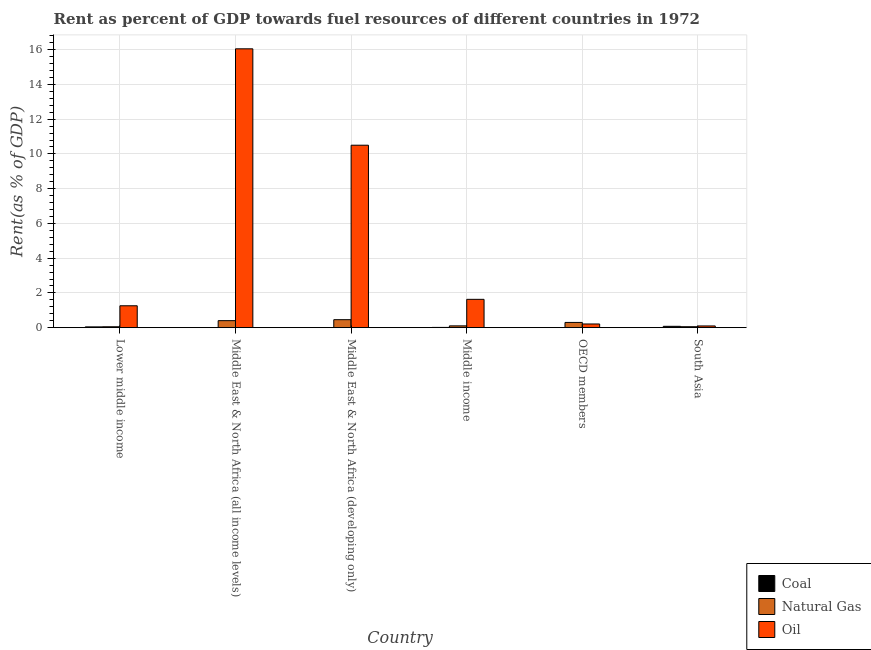How many groups of bars are there?
Provide a short and direct response. 6. Are the number of bars on each tick of the X-axis equal?
Provide a succinct answer. Yes. What is the label of the 6th group of bars from the left?
Your answer should be very brief. South Asia. In how many cases, is the number of bars for a given country not equal to the number of legend labels?
Offer a very short reply. 0. What is the rent towards coal in South Asia?
Ensure brevity in your answer.  0.08. Across all countries, what is the maximum rent towards coal?
Provide a succinct answer. 0.08. Across all countries, what is the minimum rent towards coal?
Make the answer very short. 2.27630170157113e-6. In which country was the rent towards natural gas maximum?
Give a very brief answer. Middle East & North Africa (developing only). In which country was the rent towards coal minimum?
Your answer should be compact. OECD members. What is the total rent towards coal in the graph?
Keep it short and to the point. 0.14. What is the difference between the rent towards coal in Middle East & North Africa (developing only) and that in Middle income?
Offer a terse response. -0.01. What is the difference between the rent towards coal in Lower middle income and the rent towards oil in OECD members?
Provide a short and direct response. -0.17. What is the average rent towards natural gas per country?
Keep it short and to the point. 0.23. What is the difference between the rent towards oil and rent towards coal in OECD members?
Offer a terse response. 0.21. In how many countries, is the rent towards natural gas greater than 6 %?
Ensure brevity in your answer.  0. What is the ratio of the rent towards natural gas in Middle East & North Africa (developing only) to that in South Asia?
Ensure brevity in your answer.  8.35. Is the difference between the rent towards oil in Middle East & North Africa (developing only) and Middle income greater than the difference between the rent towards natural gas in Middle East & North Africa (developing only) and Middle income?
Ensure brevity in your answer.  Yes. What is the difference between the highest and the second highest rent towards natural gas?
Your answer should be compact. 0.06. What is the difference between the highest and the lowest rent towards oil?
Your answer should be very brief. 15.95. Is the sum of the rent towards natural gas in Middle East & North Africa (all income levels) and Middle East & North Africa (developing only) greater than the maximum rent towards coal across all countries?
Provide a succinct answer. Yes. What does the 2nd bar from the left in South Asia represents?
Provide a short and direct response. Natural Gas. What does the 2nd bar from the right in Lower middle income represents?
Keep it short and to the point. Natural Gas. What is the difference between two consecutive major ticks on the Y-axis?
Your response must be concise. 2. Does the graph contain any zero values?
Give a very brief answer. No. Where does the legend appear in the graph?
Offer a very short reply. Bottom right. How are the legend labels stacked?
Offer a terse response. Vertical. What is the title of the graph?
Offer a very short reply. Rent as percent of GDP towards fuel resources of different countries in 1972. Does "Ages 0-14" appear as one of the legend labels in the graph?
Provide a succinct answer. No. What is the label or title of the X-axis?
Provide a short and direct response. Country. What is the label or title of the Y-axis?
Offer a very short reply. Rent(as % of GDP). What is the Rent(as % of GDP) of Coal in Lower middle income?
Keep it short and to the point. 0.04. What is the Rent(as % of GDP) in Natural Gas in Lower middle income?
Offer a very short reply. 0.05. What is the Rent(as % of GDP) of Oil in Lower middle income?
Your answer should be compact. 1.26. What is the Rent(as % of GDP) in Coal in Middle East & North Africa (all income levels)?
Your answer should be compact. 0. What is the Rent(as % of GDP) of Natural Gas in Middle East & North Africa (all income levels)?
Keep it short and to the point. 0.4. What is the Rent(as % of GDP) in Oil in Middle East & North Africa (all income levels)?
Give a very brief answer. 16.05. What is the Rent(as % of GDP) of Coal in Middle East & North Africa (developing only)?
Give a very brief answer. 0. What is the Rent(as % of GDP) of Natural Gas in Middle East & North Africa (developing only)?
Your response must be concise. 0.46. What is the Rent(as % of GDP) in Oil in Middle East & North Africa (developing only)?
Your answer should be very brief. 10.5. What is the Rent(as % of GDP) in Coal in Middle income?
Your answer should be very brief. 0.01. What is the Rent(as % of GDP) of Natural Gas in Middle income?
Give a very brief answer. 0.1. What is the Rent(as % of GDP) in Oil in Middle income?
Your response must be concise. 1.63. What is the Rent(as % of GDP) in Coal in OECD members?
Your answer should be compact. 2.27630170157113e-6. What is the Rent(as % of GDP) of Natural Gas in OECD members?
Give a very brief answer. 0.3. What is the Rent(as % of GDP) in Oil in OECD members?
Provide a succinct answer. 0.21. What is the Rent(as % of GDP) in Coal in South Asia?
Your answer should be compact. 0.08. What is the Rent(as % of GDP) in Natural Gas in South Asia?
Provide a short and direct response. 0.06. What is the Rent(as % of GDP) of Oil in South Asia?
Ensure brevity in your answer.  0.1. Across all countries, what is the maximum Rent(as % of GDP) of Coal?
Give a very brief answer. 0.08. Across all countries, what is the maximum Rent(as % of GDP) in Natural Gas?
Ensure brevity in your answer.  0.46. Across all countries, what is the maximum Rent(as % of GDP) of Oil?
Offer a terse response. 16.05. Across all countries, what is the minimum Rent(as % of GDP) of Coal?
Ensure brevity in your answer.  2.27630170157113e-6. Across all countries, what is the minimum Rent(as % of GDP) of Natural Gas?
Your answer should be compact. 0.05. Across all countries, what is the minimum Rent(as % of GDP) in Oil?
Ensure brevity in your answer.  0.1. What is the total Rent(as % of GDP) in Coal in the graph?
Your answer should be compact. 0.14. What is the total Rent(as % of GDP) of Natural Gas in the graph?
Provide a short and direct response. 1.37. What is the total Rent(as % of GDP) of Oil in the graph?
Your response must be concise. 29.76. What is the difference between the Rent(as % of GDP) in Coal in Lower middle income and that in Middle East & North Africa (all income levels)?
Your answer should be very brief. 0.04. What is the difference between the Rent(as % of GDP) of Natural Gas in Lower middle income and that in Middle East & North Africa (all income levels)?
Provide a succinct answer. -0.35. What is the difference between the Rent(as % of GDP) of Oil in Lower middle income and that in Middle East & North Africa (all income levels)?
Make the answer very short. -14.79. What is the difference between the Rent(as % of GDP) in Coal in Lower middle income and that in Middle East & North Africa (developing only)?
Offer a terse response. 0.04. What is the difference between the Rent(as % of GDP) of Natural Gas in Lower middle income and that in Middle East & North Africa (developing only)?
Provide a succinct answer. -0.41. What is the difference between the Rent(as % of GDP) of Oil in Lower middle income and that in Middle East & North Africa (developing only)?
Offer a very short reply. -9.24. What is the difference between the Rent(as % of GDP) of Natural Gas in Lower middle income and that in Middle income?
Make the answer very short. -0.05. What is the difference between the Rent(as % of GDP) in Oil in Lower middle income and that in Middle income?
Your answer should be very brief. -0.37. What is the difference between the Rent(as % of GDP) of Coal in Lower middle income and that in OECD members?
Your response must be concise. 0.04. What is the difference between the Rent(as % of GDP) in Natural Gas in Lower middle income and that in OECD members?
Provide a succinct answer. -0.25. What is the difference between the Rent(as % of GDP) in Oil in Lower middle income and that in OECD members?
Ensure brevity in your answer.  1.05. What is the difference between the Rent(as % of GDP) of Coal in Lower middle income and that in South Asia?
Make the answer very short. -0.03. What is the difference between the Rent(as % of GDP) of Natural Gas in Lower middle income and that in South Asia?
Ensure brevity in your answer.  -0. What is the difference between the Rent(as % of GDP) in Oil in Lower middle income and that in South Asia?
Your answer should be very brief. 1.16. What is the difference between the Rent(as % of GDP) of Coal in Middle East & North Africa (all income levels) and that in Middle East & North Africa (developing only)?
Give a very brief answer. -0. What is the difference between the Rent(as % of GDP) of Natural Gas in Middle East & North Africa (all income levels) and that in Middle East & North Africa (developing only)?
Provide a short and direct response. -0.06. What is the difference between the Rent(as % of GDP) of Oil in Middle East & North Africa (all income levels) and that in Middle East & North Africa (developing only)?
Make the answer very short. 5.55. What is the difference between the Rent(as % of GDP) in Coal in Middle East & North Africa (all income levels) and that in Middle income?
Give a very brief answer. -0.01. What is the difference between the Rent(as % of GDP) of Natural Gas in Middle East & North Africa (all income levels) and that in Middle income?
Your answer should be very brief. 0.3. What is the difference between the Rent(as % of GDP) in Oil in Middle East & North Africa (all income levels) and that in Middle income?
Ensure brevity in your answer.  14.42. What is the difference between the Rent(as % of GDP) in Natural Gas in Middle East & North Africa (all income levels) and that in OECD members?
Give a very brief answer. 0.1. What is the difference between the Rent(as % of GDP) in Oil in Middle East & North Africa (all income levels) and that in OECD members?
Your answer should be compact. 15.84. What is the difference between the Rent(as % of GDP) in Coal in Middle East & North Africa (all income levels) and that in South Asia?
Ensure brevity in your answer.  -0.08. What is the difference between the Rent(as % of GDP) in Natural Gas in Middle East & North Africa (all income levels) and that in South Asia?
Make the answer very short. 0.35. What is the difference between the Rent(as % of GDP) in Oil in Middle East & North Africa (all income levels) and that in South Asia?
Provide a succinct answer. 15.95. What is the difference between the Rent(as % of GDP) of Coal in Middle East & North Africa (developing only) and that in Middle income?
Ensure brevity in your answer.  -0.01. What is the difference between the Rent(as % of GDP) of Natural Gas in Middle East & North Africa (developing only) and that in Middle income?
Make the answer very short. 0.36. What is the difference between the Rent(as % of GDP) of Oil in Middle East & North Africa (developing only) and that in Middle income?
Offer a very short reply. 8.87. What is the difference between the Rent(as % of GDP) of Coal in Middle East & North Africa (developing only) and that in OECD members?
Your answer should be compact. 0. What is the difference between the Rent(as % of GDP) in Natural Gas in Middle East & North Africa (developing only) and that in OECD members?
Offer a very short reply. 0.16. What is the difference between the Rent(as % of GDP) of Oil in Middle East & North Africa (developing only) and that in OECD members?
Provide a succinct answer. 10.29. What is the difference between the Rent(as % of GDP) of Coal in Middle East & North Africa (developing only) and that in South Asia?
Provide a short and direct response. -0.08. What is the difference between the Rent(as % of GDP) in Natural Gas in Middle East & North Africa (developing only) and that in South Asia?
Your answer should be compact. 0.4. What is the difference between the Rent(as % of GDP) in Oil in Middle East & North Africa (developing only) and that in South Asia?
Your answer should be very brief. 10.4. What is the difference between the Rent(as % of GDP) of Coal in Middle income and that in OECD members?
Keep it short and to the point. 0.01. What is the difference between the Rent(as % of GDP) of Natural Gas in Middle income and that in OECD members?
Your answer should be compact. -0.2. What is the difference between the Rent(as % of GDP) of Oil in Middle income and that in OECD members?
Your answer should be compact. 1.42. What is the difference between the Rent(as % of GDP) in Coal in Middle income and that in South Asia?
Offer a terse response. -0.06. What is the difference between the Rent(as % of GDP) of Natural Gas in Middle income and that in South Asia?
Your answer should be very brief. 0.05. What is the difference between the Rent(as % of GDP) in Oil in Middle income and that in South Asia?
Your response must be concise. 1.53. What is the difference between the Rent(as % of GDP) in Coal in OECD members and that in South Asia?
Provide a short and direct response. -0.08. What is the difference between the Rent(as % of GDP) in Natural Gas in OECD members and that in South Asia?
Your answer should be very brief. 0.25. What is the difference between the Rent(as % of GDP) in Oil in OECD members and that in South Asia?
Offer a very short reply. 0.11. What is the difference between the Rent(as % of GDP) in Coal in Lower middle income and the Rent(as % of GDP) in Natural Gas in Middle East & North Africa (all income levels)?
Give a very brief answer. -0.36. What is the difference between the Rent(as % of GDP) of Coal in Lower middle income and the Rent(as % of GDP) of Oil in Middle East & North Africa (all income levels)?
Ensure brevity in your answer.  -16.01. What is the difference between the Rent(as % of GDP) in Natural Gas in Lower middle income and the Rent(as % of GDP) in Oil in Middle East & North Africa (all income levels)?
Provide a succinct answer. -16. What is the difference between the Rent(as % of GDP) in Coal in Lower middle income and the Rent(as % of GDP) in Natural Gas in Middle East & North Africa (developing only)?
Offer a terse response. -0.41. What is the difference between the Rent(as % of GDP) of Coal in Lower middle income and the Rent(as % of GDP) of Oil in Middle East & North Africa (developing only)?
Keep it short and to the point. -10.46. What is the difference between the Rent(as % of GDP) in Natural Gas in Lower middle income and the Rent(as % of GDP) in Oil in Middle East & North Africa (developing only)?
Your answer should be compact. -10.45. What is the difference between the Rent(as % of GDP) of Coal in Lower middle income and the Rent(as % of GDP) of Natural Gas in Middle income?
Provide a succinct answer. -0.06. What is the difference between the Rent(as % of GDP) of Coal in Lower middle income and the Rent(as % of GDP) of Oil in Middle income?
Your response must be concise. -1.59. What is the difference between the Rent(as % of GDP) of Natural Gas in Lower middle income and the Rent(as % of GDP) of Oil in Middle income?
Offer a terse response. -1.58. What is the difference between the Rent(as % of GDP) in Coal in Lower middle income and the Rent(as % of GDP) in Natural Gas in OECD members?
Provide a short and direct response. -0.26. What is the difference between the Rent(as % of GDP) of Coal in Lower middle income and the Rent(as % of GDP) of Oil in OECD members?
Your answer should be compact. -0.17. What is the difference between the Rent(as % of GDP) in Natural Gas in Lower middle income and the Rent(as % of GDP) in Oil in OECD members?
Make the answer very short. -0.16. What is the difference between the Rent(as % of GDP) in Coal in Lower middle income and the Rent(as % of GDP) in Natural Gas in South Asia?
Offer a very short reply. -0.01. What is the difference between the Rent(as % of GDP) in Coal in Lower middle income and the Rent(as % of GDP) in Oil in South Asia?
Ensure brevity in your answer.  -0.05. What is the difference between the Rent(as % of GDP) of Natural Gas in Lower middle income and the Rent(as % of GDP) of Oil in South Asia?
Give a very brief answer. -0.05. What is the difference between the Rent(as % of GDP) in Coal in Middle East & North Africa (all income levels) and the Rent(as % of GDP) in Natural Gas in Middle East & North Africa (developing only)?
Your answer should be very brief. -0.46. What is the difference between the Rent(as % of GDP) in Coal in Middle East & North Africa (all income levels) and the Rent(as % of GDP) in Oil in Middle East & North Africa (developing only)?
Ensure brevity in your answer.  -10.5. What is the difference between the Rent(as % of GDP) in Natural Gas in Middle East & North Africa (all income levels) and the Rent(as % of GDP) in Oil in Middle East & North Africa (developing only)?
Ensure brevity in your answer.  -10.1. What is the difference between the Rent(as % of GDP) in Coal in Middle East & North Africa (all income levels) and the Rent(as % of GDP) in Natural Gas in Middle income?
Provide a succinct answer. -0.1. What is the difference between the Rent(as % of GDP) in Coal in Middle East & North Africa (all income levels) and the Rent(as % of GDP) in Oil in Middle income?
Your answer should be compact. -1.63. What is the difference between the Rent(as % of GDP) of Natural Gas in Middle East & North Africa (all income levels) and the Rent(as % of GDP) of Oil in Middle income?
Offer a very short reply. -1.23. What is the difference between the Rent(as % of GDP) in Coal in Middle East & North Africa (all income levels) and the Rent(as % of GDP) in Natural Gas in OECD members?
Your answer should be very brief. -0.3. What is the difference between the Rent(as % of GDP) of Coal in Middle East & North Africa (all income levels) and the Rent(as % of GDP) of Oil in OECD members?
Give a very brief answer. -0.21. What is the difference between the Rent(as % of GDP) in Natural Gas in Middle East & North Africa (all income levels) and the Rent(as % of GDP) in Oil in OECD members?
Ensure brevity in your answer.  0.19. What is the difference between the Rent(as % of GDP) of Coal in Middle East & North Africa (all income levels) and the Rent(as % of GDP) of Natural Gas in South Asia?
Your response must be concise. -0.05. What is the difference between the Rent(as % of GDP) of Coal in Middle East & North Africa (all income levels) and the Rent(as % of GDP) of Oil in South Asia?
Make the answer very short. -0.1. What is the difference between the Rent(as % of GDP) of Natural Gas in Middle East & North Africa (all income levels) and the Rent(as % of GDP) of Oil in South Asia?
Ensure brevity in your answer.  0.3. What is the difference between the Rent(as % of GDP) of Coal in Middle East & North Africa (developing only) and the Rent(as % of GDP) of Natural Gas in Middle income?
Ensure brevity in your answer.  -0.1. What is the difference between the Rent(as % of GDP) in Coal in Middle East & North Africa (developing only) and the Rent(as % of GDP) in Oil in Middle income?
Your answer should be compact. -1.63. What is the difference between the Rent(as % of GDP) in Natural Gas in Middle East & North Africa (developing only) and the Rent(as % of GDP) in Oil in Middle income?
Your response must be concise. -1.17. What is the difference between the Rent(as % of GDP) in Coal in Middle East & North Africa (developing only) and the Rent(as % of GDP) in Natural Gas in OECD members?
Give a very brief answer. -0.3. What is the difference between the Rent(as % of GDP) of Coal in Middle East & North Africa (developing only) and the Rent(as % of GDP) of Oil in OECD members?
Your response must be concise. -0.21. What is the difference between the Rent(as % of GDP) in Natural Gas in Middle East & North Africa (developing only) and the Rent(as % of GDP) in Oil in OECD members?
Your response must be concise. 0.25. What is the difference between the Rent(as % of GDP) of Coal in Middle East & North Africa (developing only) and the Rent(as % of GDP) of Natural Gas in South Asia?
Your response must be concise. -0.05. What is the difference between the Rent(as % of GDP) in Coal in Middle East & North Africa (developing only) and the Rent(as % of GDP) in Oil in South Asia?
Offer a terse response. -0.1. What is the difference between the Rent(as % of GDP) in Natural Gas in Middle East & North Africa (developing only) and the Rent(as % of GDP) in Oil in South Asia?
Offer a terse response. 0.36. What is the difference between the Rent(as % of GDP) in Coal in Middle income and the Rent(as % of GDP) in Natural Gas in OECD members?
Make the answer very short. -0.29. What is the difference between the Rent(as % of GDP) in Coal in Middle income and the Rent(as % of GDP) in Oil in OECD members?
Provide a short and direct response. -0.2. What is the difference between the Rent(as % of GDP) in Natural Gas in Middle income and the Rent(as % of GDP) in Oil in OECD members?
Give a very brief answer. -0.11. What is the difference between the Rent(as % of GDP) in Coal in Middle income and the Rent(as % of GDP) in Natural Gas in South Asia?
Keep it short and to the point. -0.04. What is the difference between the Rent(as % of GDP) in Coal in Middle income and the Rent(as % of GDP) in Oil in South Asia?
Your answer should be very brief. -0.08. What is the difference between the Rent(as % of GDP) of Natural Gas in Middle income and the Rent(as % of GDP) of Oil in South Asia?
Offer a very short reply. 0.01. What is the difference between the Rent(as % of GDP) in Coal in OECD members and the Rent(as % of GDP) in Natural Gas in South Asia?
Provide a short and direct response. -0.06. What is the difference between the Rent(as % of GDP) of Coal in OECD members and the Rent(as % of GDP) of Oil in South Asia?
Provide a short and direct response. -0.1. What is the difference between the Rent(as % of GDP) in Natural Gas in OECD members and the Rent(as % of GDP) in Oil in South Asia?
Give a very brief answer. 0.2. What is the average Rent(as % of GDP) in Coal per country?
Your answer should be compact. 0.02. What is the average Rent(as % of GDP) in Natural Gas per country?
Your answer should be compact. 0.23. What is the average Rent(as % of GDP) in Oil per country?
Provide a succinct answer. 4.96. What is the difference between the Rent(as % of GDP) in Coal and Rent(as % of GDP) in Natural Gas in Lower middle income?
Your answer should be very brief. -0.01. What is the difference between the Rent(as % of GDP) of Coal and Rent(as % of GDP) of Oil in Lower middle income?
Your answer should be very brief. -1.22. What is the difference between the Rent(as % of GDP) in Natural Gas and Rent(as % of GDP) in Oil in Lower middle income?
Your answer should be very brief. -1.21. What is the difference between the Rent(as % of GDP) in Coal and Rent(as % of GDP) in Natural Gas in Middle East & North Africa (all income levels)?
Ensure brevity in your answer.  -0.4. What is the difference between the Rent(as % of GDP) of Coal and Rent(as % of GDP) of Oil in Middle East & North Africa (all income levels)?
Provide a succinct answer. -16.05. What is the difference between the Rent(as % of GDP) in Natural Gas and Rent(as % of GDP) in Oil in Middle East & North Africa (all income levels)?
Provide a succinct answer. -15.65. What is the difference between the Rent(as % of GDP) of Coal and Rent(as % of GDP) of Natural Gas in Middle East & North Africa (developing only)?
Give a very brief answer. -0.46. What is the difference between the Rent(as % of GDP) in Coal and Rent(as % of GDP) in Oil in Middle East & North Africa (developing only)?
Offer a terse response. -10.5. What is the difference between the Rent(as % of GDP) in Natural Gas and Rent(as % of GDP) in Oil in Middle East & North Africa (developing only)?
Your answer should be compact. -10.04. What is the difference between the Rent(as % of GDP) in Coal and Rent(as % of GDP) in Natural Gas in Middle income?
Your answer should be very brief. -0.09. What is the difference between the Rent(as % of GDP) of Coal and Rent(as % of GDP) of Oil in Middle income?
Offer a very short reply. -1.62. What is the difference between the Rent(as % of GDP) in Natural Gas and Rent(as % of GDP) in Oil in Middle income?
Your answer should be very brief. -1.53. What is the difference between the Rent(as % of GDP) of Coal and Rent(as % of GDP) of Natural Gas in OECD members?
Provide a succinct answer. -0.3. What is the difference between the Rent(as % of GDP) in Coal and Rent(as % of GDP) in Oil in OECD members?
Your response must be concise. -0.21. What is the difference between the Rent(as % of GDP) of Natural Gas and Rent(as % of GDP) of Oil in OECD members?
Ensure brevity in your answer.  0.09. What is the difference between the Rent(as % of GDP) of Coal and Rent(as % of GDP) of Natural Gas in South Asia?
Ensure brevity in your answer.  0.02. What is the difference between the Rent(as % of GDP) in Coal and Rent(as % of GDP) in Oil in South Asia?
Your answer should be very brief. -0.02. What is the difference between the Rent(as % of GDP) of Natural Gas and Rent(as % of GDP) of Oil in South Asia?
Offer a very short reply. -0.04. What is the ratio of the Rent(as % of GDP) of Coal in Lower middle income to that in Middle East & North Africa (all income levels)?
Provide a short and direct response. 43.7. What is the ratio of the Rent(as % of GDP) of Natural Gas in Lower middle income to that in Middle East & North Africa (all income levels)?
Your response must be concise. 0.13. What is the ratio of the Rent(as % of GDP) of Oil in Lower middle income to that in Middle East & North Africa (all income levels)?
Keep it short and to the point. 0.08. What is the ratio of the Rent(as % of GDP) of Coal in Lower middle income to that in Middle East & North Africa (developing only)?
Make the answer very short. 29.76. What is the ratio of the Rent(as % of GDP) of Natural Gas in Lower middle income to that in Middle East & North Africa (developing only)?
Your answer should be very brief. 0.11. What is the ratio of the Rent(as % of GDP) in Oil in Lower middle income to that in Middle East & North Africa (developing only)?
Provide a succinct answer. 0.12. What is the ratio of the Rent(as % of GDP) of Coal in Lower middle income to that in Middle income?
Provide a succinct answer. 3.06. What is the ratio of the Rent(as % of GDP) of Natural Gas in Lower middle income to that in Middle income?
Provide a short and direct response. 0.5. What is the ratio of the Rent(as % of GDP) in Oil in Lower middle income to that in Middle income?
Give a very brief answer. 0.77. What is the ratio of the Rent(as % of GDP) in Coal in Lower middle income to that in OECD members?
Offer a very short reply. 1.96e+04. What is the ratio of the Rent(as % of GDP) in Natural Gas in Lower middle income to that in OECD members?
Provide a short and direct response. 0.17. What is the ratio of the Rent(as % of GDP) in Oil in Lower middle income to that in OECD members?
Your answer should be compact. 5.94. What is the ratio of the Rent(as % of GDP) of Coal in Lower middle income to that in South Asia?
Your response must be concise. 0.58. What is the ratio of the Rent(as % of GDP) in Natural Gas in Lower middle income to that in South Asia?
Provide a short and direct response. 0.95. What is the ratio of the Rent(as % of GDP) of Oil in Lower middle income to that in South Asia?
Offer a terse response. 12.79. What is the ratio of the Rent(as % of GDP) in Coal in Middle East & North Africa (all income levels) to that in Middle East & North Africa (developing only)?
Keep it short and to the point. 0.68. What is the ratio of the Rent(as % of GDP) of Natural Gas in Middle East & North Africa (all income levels) to that in Middle East & North Africa (developing only)?
Offer a terse response. 0.88. What is the ratio of the Rent(as % of GDP) of Oil in Middle East & North Africa (all income levels) to that in Middle East & North Africa (developing only)?
Provide a succinct answer. 1.53. What is the ratio of the Rent(as % of GDP) of Coal in Middle East & North Africa (all income levels) to that in Middle income?
Ensure brevity in your answer.  0.07. What is the ratio of the Rent(as % of GDP) of Natural Gas in Middle East & North Africa (all income levels) to that in Middle income?
Make the answer very short. 3.89. What is the ratio of the Rent(as % of GDP) of Oil in Middle East & North Africa (all income levels) to that in Middle income?
Provide a succinct answer. 9.84. What is the ratio of the Rent(as % of GDP) of Coal in Middle East & North Africa (all income levels) to that in OECD members?
Keep it short and to the point. 448.35. What is the ratio of the Rent(as % of GDP) of Natural Gas in Middle East & North Africa (all income levels) to that in OECD members?
Give a very brief answer. 1.34. What is the ratio of the Rent(as % of GDP) in Oil in Middle East & North Africa (all income levels) to that in OECD members?
Give a very brief answer. 75.64. What is the ratio of the Rent(as % of GDP) in Coal in Middle East & North Africa (all income levels) to that in South Asia?
Offer a very short reply. 0.01. What is the ratio of the Rent(as % of GDP) in Natural Gas in Middle East & North Africa (all income levels) to that in South Asia?
Ensure brevity in your answer.  7.33. What is the ratio of the Rent(as % of GDP) in Oil in Middle East & North Africa (all income levels) to that in South Asia?
Provide a short and direct response. 162.9. What is the ratio of the Rent(as % of GDP) of Coal in Middle East & North Africa (developing only) to that in Middle income?
Provide a short and direct response. 0.1. What is the ratio of the Rent(as % of GDP) of Natural Gas in Middle East & North Africa (developing only) to that in Middle income?
Ensure brevity in your answer.  4.44. What is the ratio of the Rent(as % of GDP) of Oil in Middle East & North Africa (developing only) to that in Middle income?
Your response must be concise. 6.44. What is the ratio of the Rent(as % of GDP) of Coal in Middle East & North Africa (developing only) to that in OECD members?
Provide a succinct answer. 658.36. What is the ratio of the Rent(as % of GDP) of Natural Gas in Middle East & North Africa (developing only) to that in OECD members?
Give a very brief answer. 1.53. What is the ratio of the Rent(as % of GDP) of Oil in Middle East & North Africa (developing only) to that in OECD members?
Make the answer very short. 49.49. What is the ratio of the Rent(as % of GDP) in Coal in Middle East & North Africa (developing only) to that in South Asia?
Keep it short and to the point. 0.02. What is the ratio of the Rent(as % of GDP) in Natural Gas in Middle East & North Africa (developing only) to that in South Asia?
Make the answer very short. 8.35. What is the ratio of the Rent(as % of GDP) in Oil in Middle East & North Africa (developing only) to that in South Asia?
Provide a succinct answer. 106.59. What is the ratio of the Rent(as % of GDP) of Coal in Middle income to that in OECD members?
Keep it short and to the point. 6403.91. What is the ratio of the Rent(as % of GDP) in Natural Gas in Middle income to that in OECD members?
Ensure brevity in your answer.  0.34. What is the ratio of the Rent(as % of GDP) in Oil in Middle income to that in OECD members?
Ensure brevity in your answer.  7.68. What is the ratio of the Rent(as % of GDP) of Coal in Middle income to that in South Asia?
Ensure brevity in your answer.  0.19. What is the ratio of the Rent(as % of GDP) of Natural Gas in Middle income to that in South Asia?
Provide a succinct answer. 1.88. What is the ratio of the Rent(as % of GDP) in Oil in Middle income to that in South Asia?
Ensure brevity in your answer.  16.55. What is the ratio of the Rent(as % of GDP) in Coal in OECD members to that in South Asia?
Make the answer very short. 0. What is the ratio of the Rent(as % of GDP) in Natural Gas in OECD members to that in South Asia?
Your answer should be very brief. 5.47. What is the ratio of the Rent(as % of GDP) in Oil in OECD members to that in South Asia?
Ensure brevity in your answer.  2.15. What is the difference between the highest and the second highest Rent(as % of GDP) of Coal?
Provide a succinct answer. 0.03. What is the difference between the highest and the second highest Rent(as % of GDP) of Natural Gas?
Give a very brief answer. 0.06. What is the difference between the highest and the second highest Rent(as % of GDP) of Oil?
Give a very brief answer. 5.55. What is the difference between the highest and the lowest Rent(as % of GDP) of Coal?
Provide a short and direct response. 0.08. What is the difference between the highest and the lowest Rent(as % of GDP) in Natural Gas?
Offer a terse response. 0.41. What is the difference between the highest and the lowest Rent(as % of GDP) of Oil?
Give a very brief answer. 15.95. 